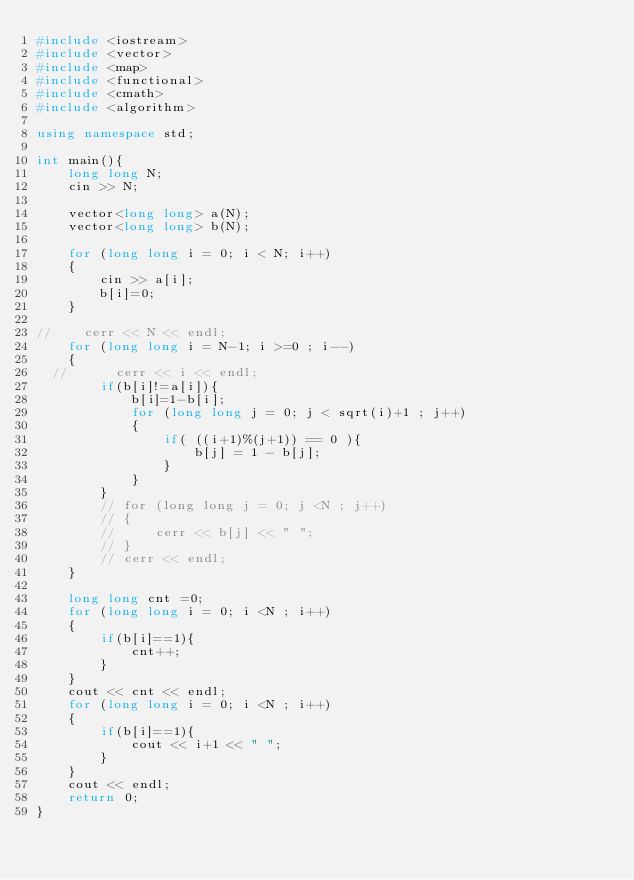Convert code to text. <code><loc_0><loc_0><loc_500><loc_500><_C++_>#include <iostream>
#include <vector>
#include <map>
#include <functional>
#include <cmath>
#include <algorithm>

using namespace std;

int main(){
    long long N;
    cin >> N;

    vector<long long> a(N);
    vector<long long> b(N);

    for (long long i = 0; i < N; i++)
    {
        cin >> a[i];
        b[i]=0;
    }

//    cerr << N << endl;
    for (long long i = N-1; i >=0 ; i--)
    {
  //      cerr << i << endl;
        if(b[i]!=a[i]){
            b[i]=1-b[i];
            for (long long j = 0; j < sqrt(i)+1 ; j++)
            {
                if( ((i+1)%(j+1)) == 0 ){
                    b[j] = 1 - b[j];
                }
            }
        }
        // for (long long j = 0; j <N ; j++)
        // {
        //     cerr << b[j] << " ";
        // }
        // cerr << endl;
    }

    long long cnt =0;
    for (long long i = 0; i <N ; i++)
    {
        if(b[i]==1){
            cnt++;
        }
    }
    cout << cnt << endl;
    for (long long i = 0; i <N ; i++)
    {
        if(b[i]==1){
            cout << i+1 << " ";
        }
    }
    cout << endl;  
    return 0;
}
</code> 